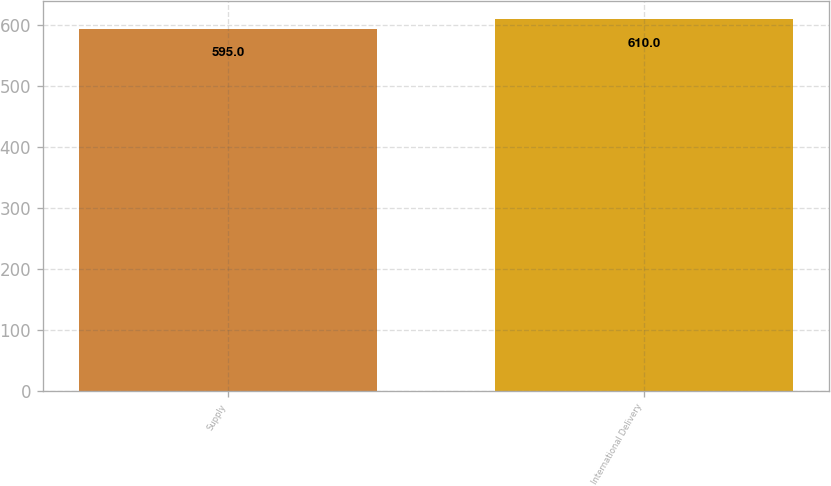Convert chart to OTSL. <chart><loc_0><loc_0><loc_500><loc_500><bar_chart><fcel>Supply<fcel>International Delivery<nl><fcel>595<fcel>610<nl></chart> 